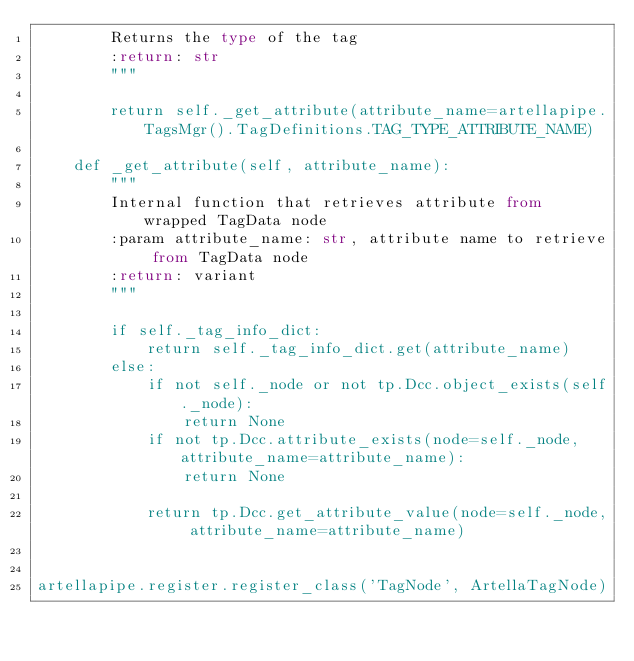<code> <loc_0><loc_0><loc_500><loc_500><_Python_>        Returns the type of the tag
        :return: str
        """

        return self._get_attribute(attribute_name=artellapipe.TagsMgr().TagDefinitions.TAG_TYPE_ATTRIBUTE_NAME)

    def _get_attribute(self, attribute_name):
        """
        Internal function that retrieves attribute from wrapped TagData node
        :param attribute_name: str, attribute name to retrieve from TagData node
        :return: variant
        """

        if self._tag_info_dict:
            return self._tag_info_dict.get(attribute_name)
        else:
            if not self._node or not tp.Dcc.object_exists(self._node):
                return None
            if not tp.Dcc.attribute_exists(node=self._node, attribute_name=attribute_name):
                return None

            return tp.Dcc.get_attribute_value(node=self._node, attribute_name=attribute_name)


artellapipe.register.register_class('TagNode', ArtellaTagNode)
</code> 